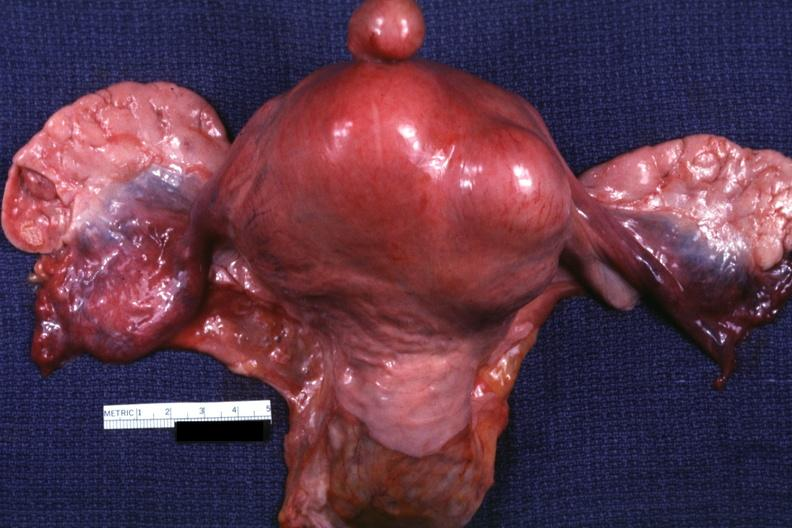does all the fat necrosis show unopened uterus tubes and ovaries?
Answer the question using a single word or phrase. No 